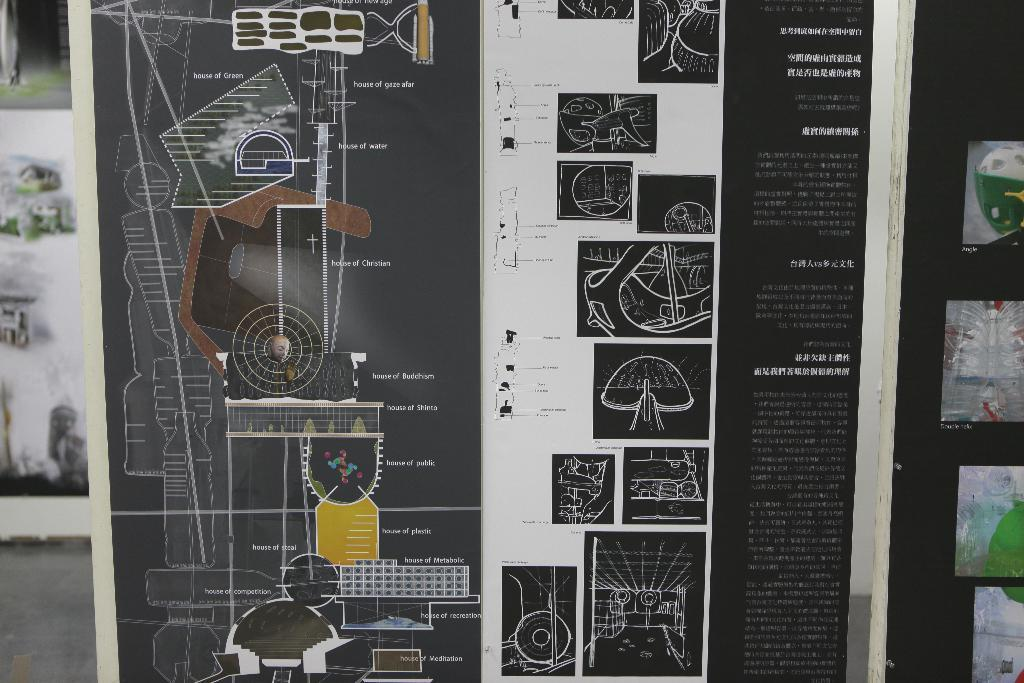What is present in the image that contains both text and images? There is a banner in the image that contains text and images. Can you describe the content of the banner? The banner contains text and images, but the specific content cannot be determined from the provided facts. What type of ice can be seen melting on the thrill spot in the image? There is no ice or thrill spot present in the image; it only contains a banner with text and images. 